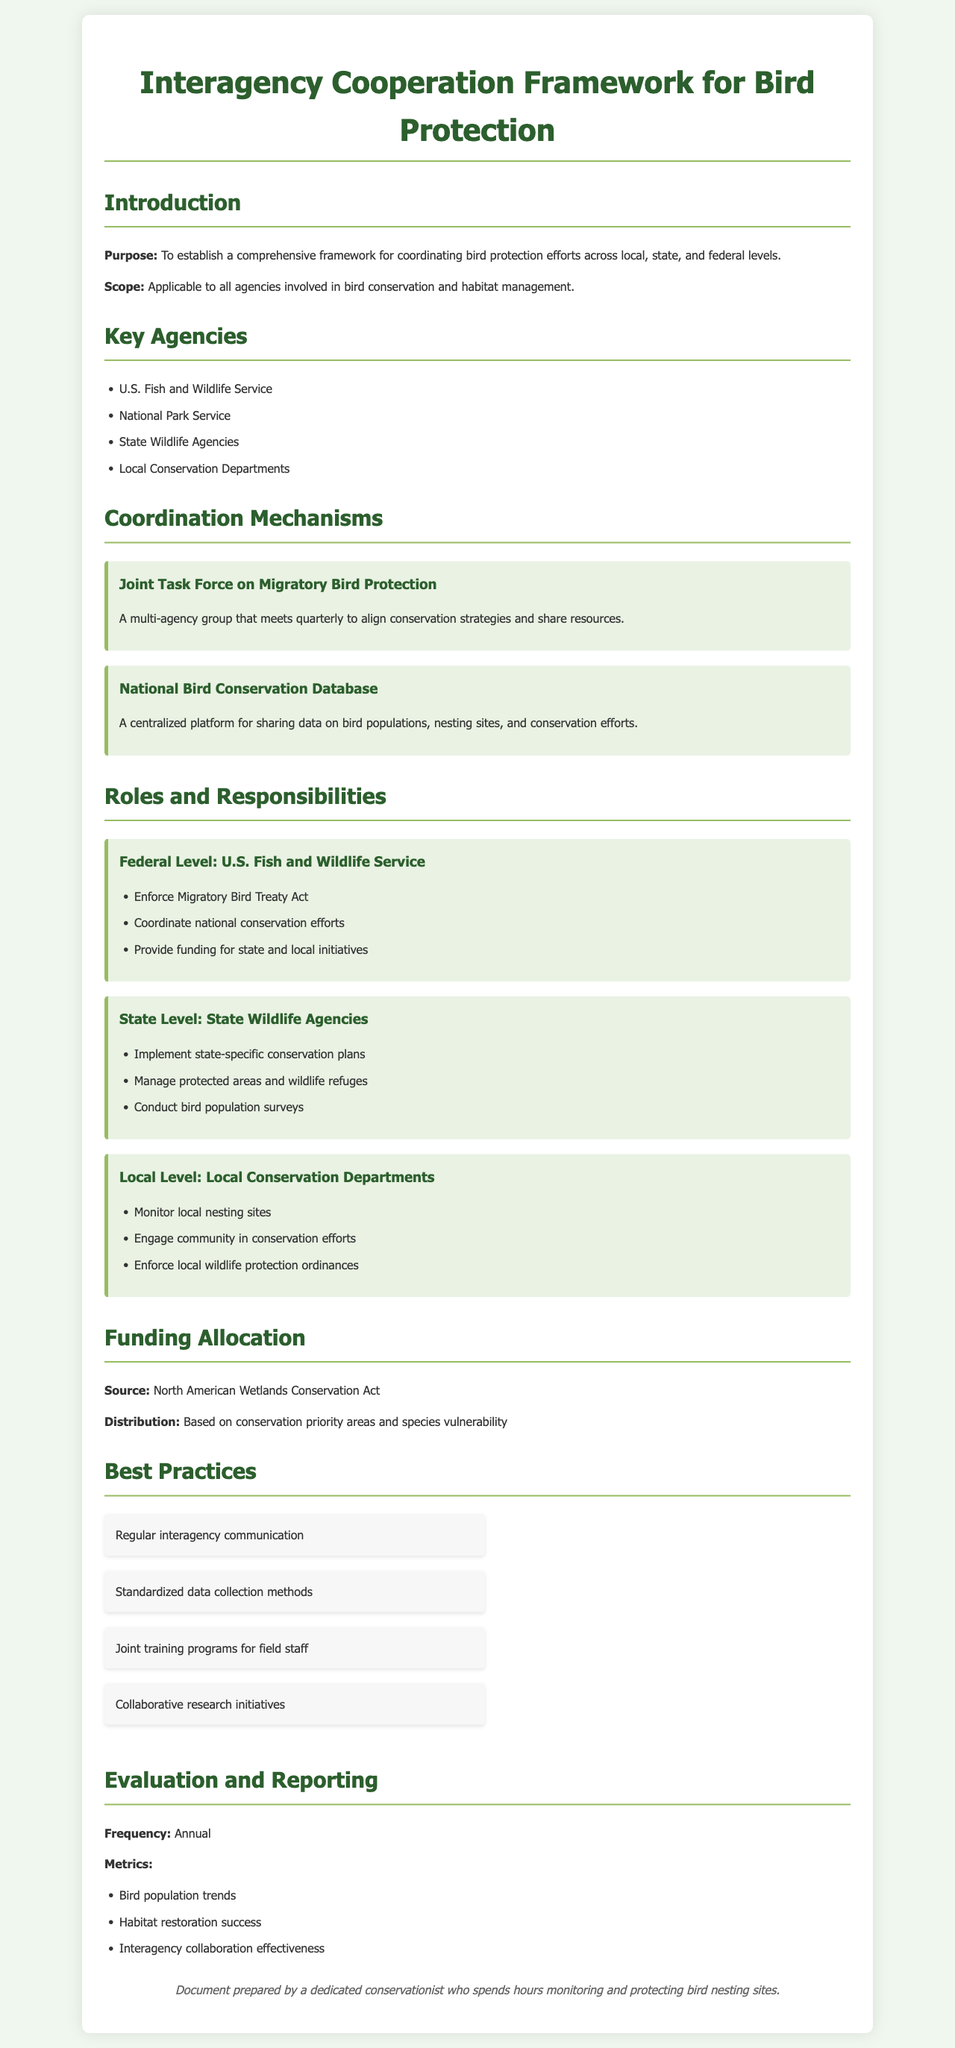What is the purpose of the document? The purpose of the document is to establish a comprehensive framework for coordinating bird protection efforts across local, state, and federal levels.
Answer: To establish a comprehensive framework for coordinating bird protection efforts across local, state, and federal levels Which agency is responsible for enforcing the Migratory Bird Treaty Act? The U.S. Fish and Wildlife Service is identified as the agency responsible for enforcing the Migratory Bird Treaty Act.
Answer: U.S. Fish and Wildlife Service How often does the Joint Task Force on Migratory Bird Protection meet? The document states that the Joint Task Force on Migratory Bird Protection meets quarterly, which indicates a frequency of four times a year.
Answer: Quarterly What are the main funding sources mentioned in the document? The primary funding source mentioned in the document is the North American Wetlands Conservation Act.
Answer: North American Wetlands Conservation Act List one of the best practices for interagency cooperation. The document provides multiple examples of best practices; one of them is regular interagency communication.
Answer: Regular interagency communication What is the frequency of evaluation and reporting? The document specifies that the evaluation and reporting process occurs annually.
Answer: Annual Which agency manages protected areas and wildlife refuges? The State Wildlife Agencies are responsible for managing protected areas and wildlife refuges as outlined in their roles and responsibilities.
Answer: State Wildlife Agencies What metrics are used for evaluation? Key metrics mentioned for evaluation include bird population trends, habitat restoration success, and interagency collaboration effectiveness.
Answer: Bird population trends, habitat restoration success, interagency collaboration effectiveness 